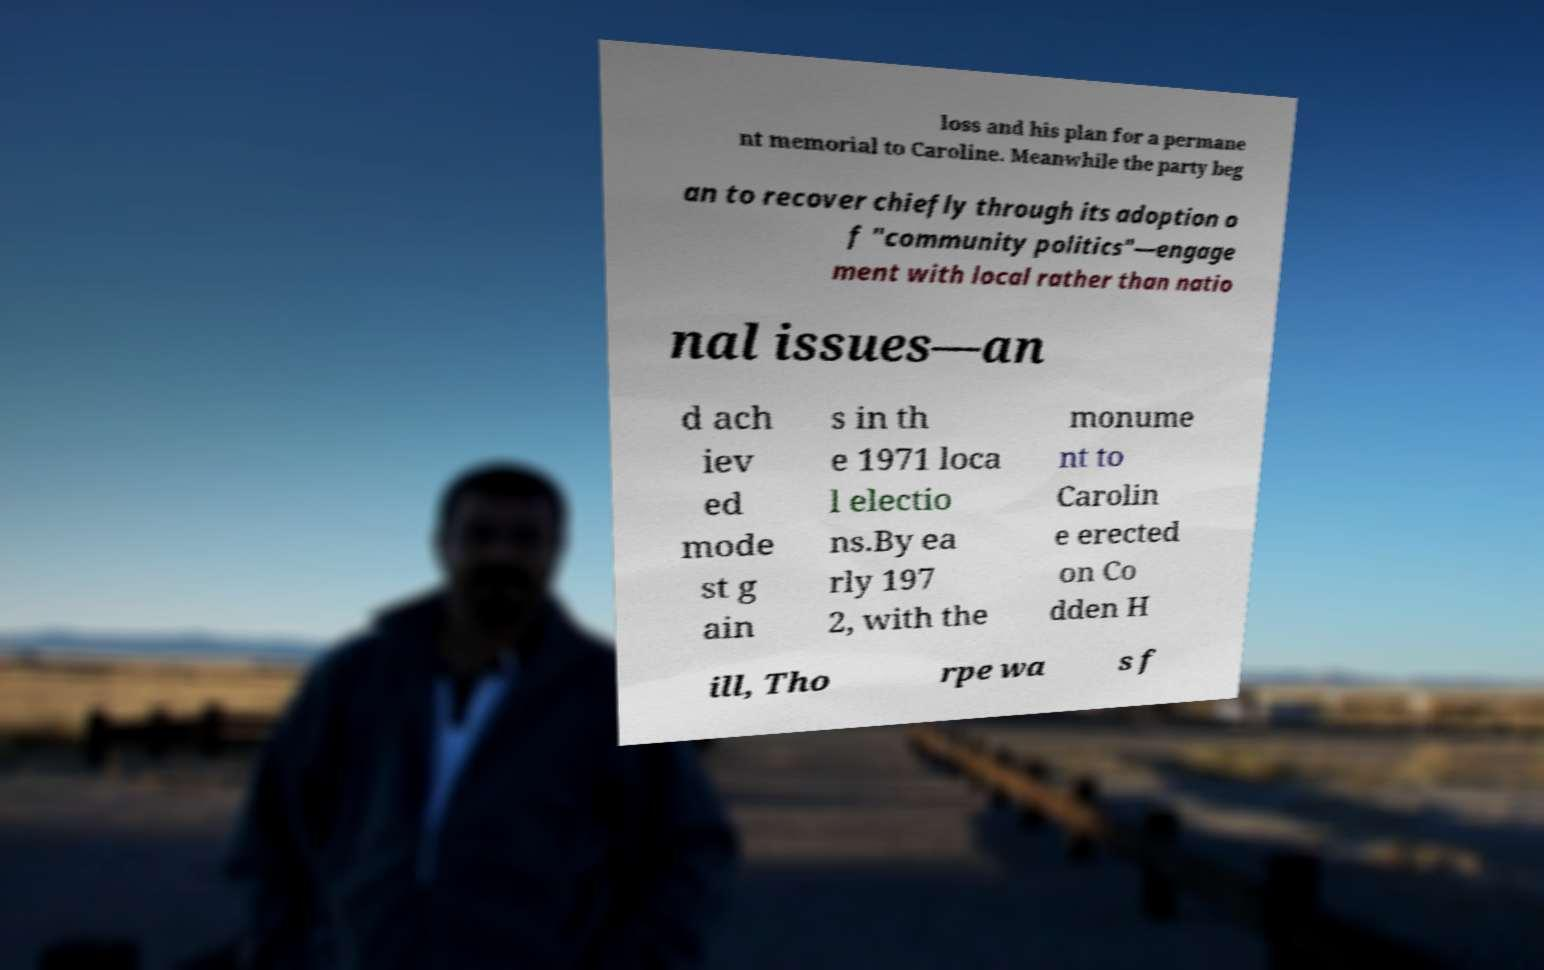Can you accurately transcribe the text from the provided image for me? loss and his plan for a permane nt memorial to Caroline. Meanwhile the party beg an to recover chiefly through its adoption o f "community politics"—engage ment with local rather than natio nal issues—an d ach iev ed mode st g ain s in th e 1971 loca l electio ns.By ea rly 197 2, with the monume nt to Carolin e erected on Co dden H ill, Tho rpe wa s f 